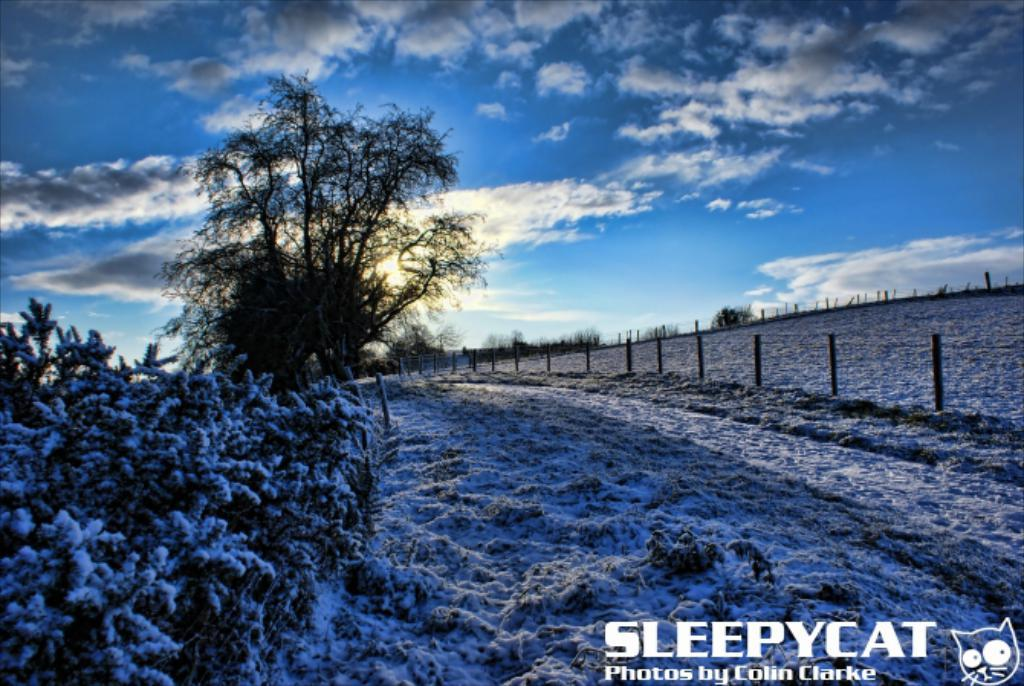What type of vegetation can be seen in the image? There are trees in the image. What type of landscape is visible in the image? There are fields in the image. What is used to separate or enclose the fields in the image? There is fencing in the image. What is the weather like in the image? There is snow in the image, and the sky is partially cloudy. What can be seen in the background of the image? There are trees and fencing in the background of the image. How much money is being exchanged between the trees in the image? There is no money exchange depicted in the image; it features trees, fields, fencing, snow, and a partially cloudy sky. Can you tell me how many mittens are hanging on the trees in the image? There are no mittens present in the image; it features trees, fields, fencing, snow, and a partially cloudy sky. 